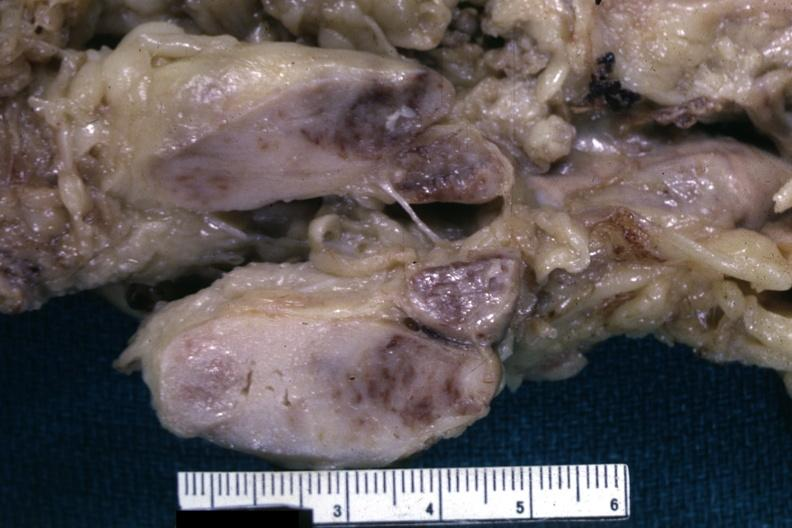s matting history of this case unknown could have been a seminoma see other slides?
Answer the question using a single word or phrase. Yes 